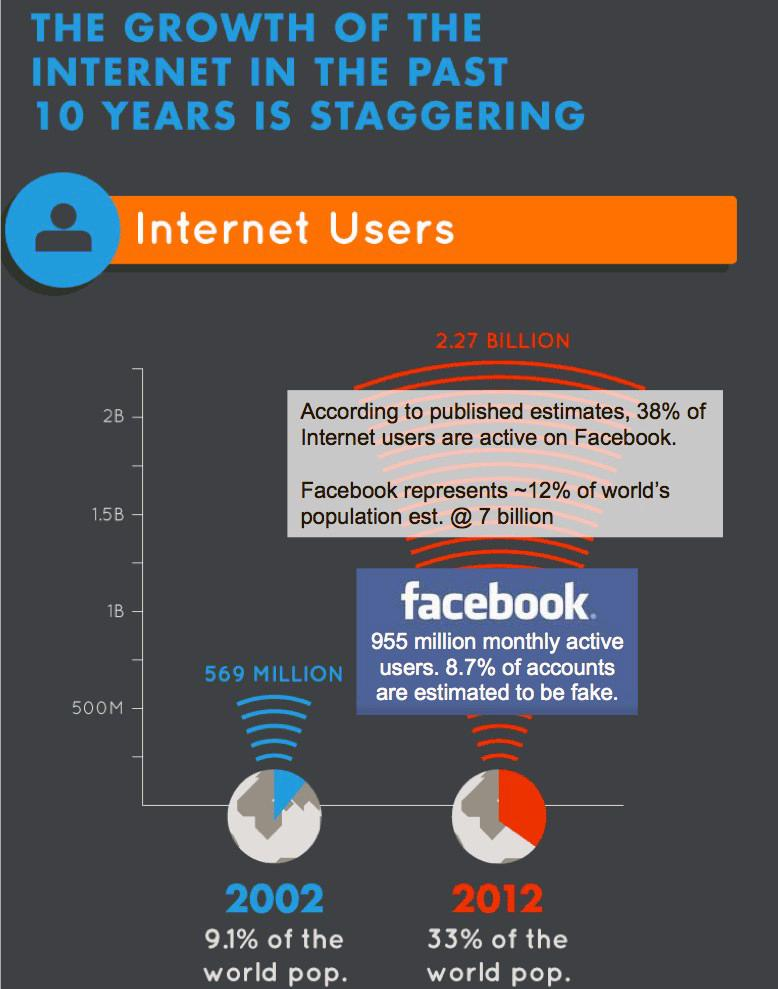Outline some significant characteristics in this image. As of 2012, there were approximately 2.27 BILLION Facebook users. As of 2002, the number of Facebook users was approximately 569 million. 